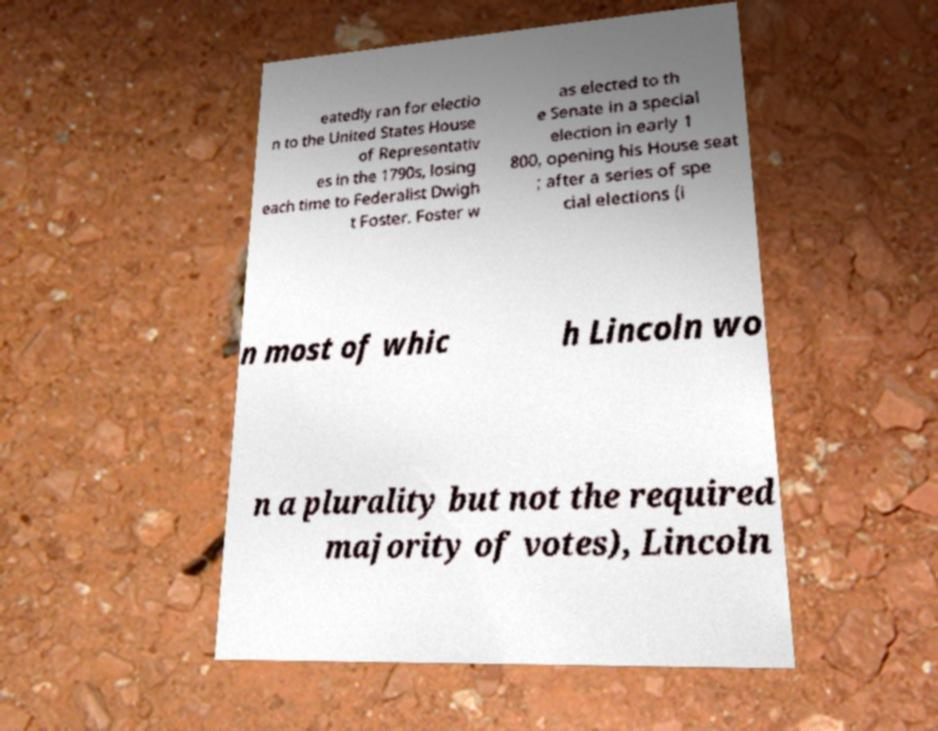For documentation purposes, I need the text within this image transcribed. Could you provide that? eatedly ran for electio n to the United States House of Representativ es in the 1790s, losing each time to Federalist Dwigh t Foster. Foster w as elected to th e Senate in a special election in early 1 800, opening his House seat ; after a series of spe cial elections (i n most of whic h Lincoln wo n a plurality but not the required majority of votes), Lincoln 